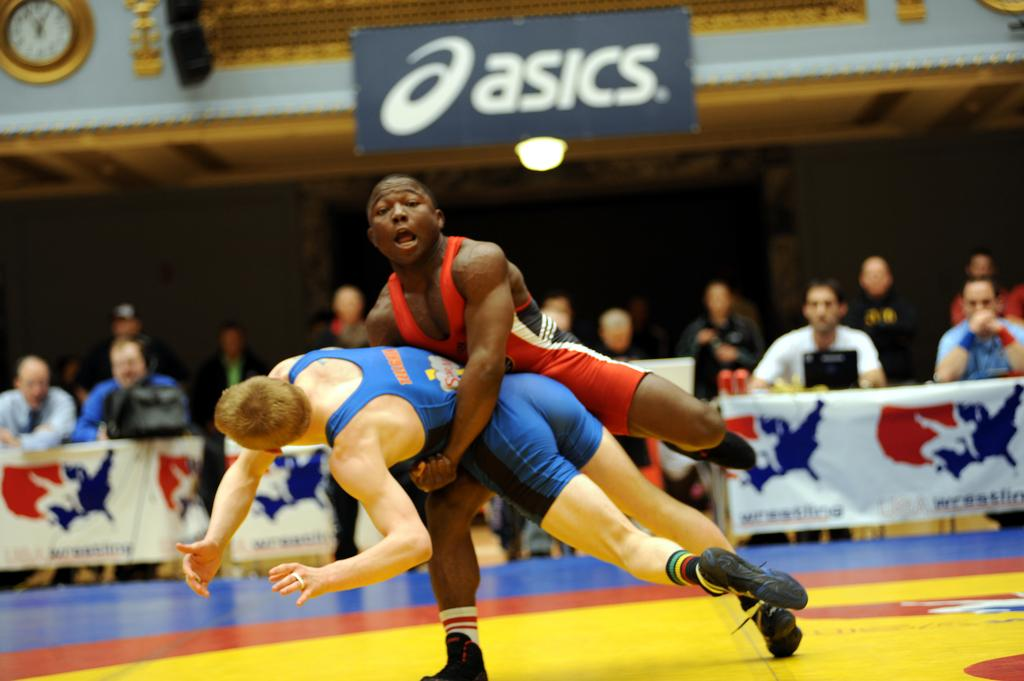<image>
Relay a brief, clear account of the picture shown. one of the sponsors of the wrestling match is Asics 